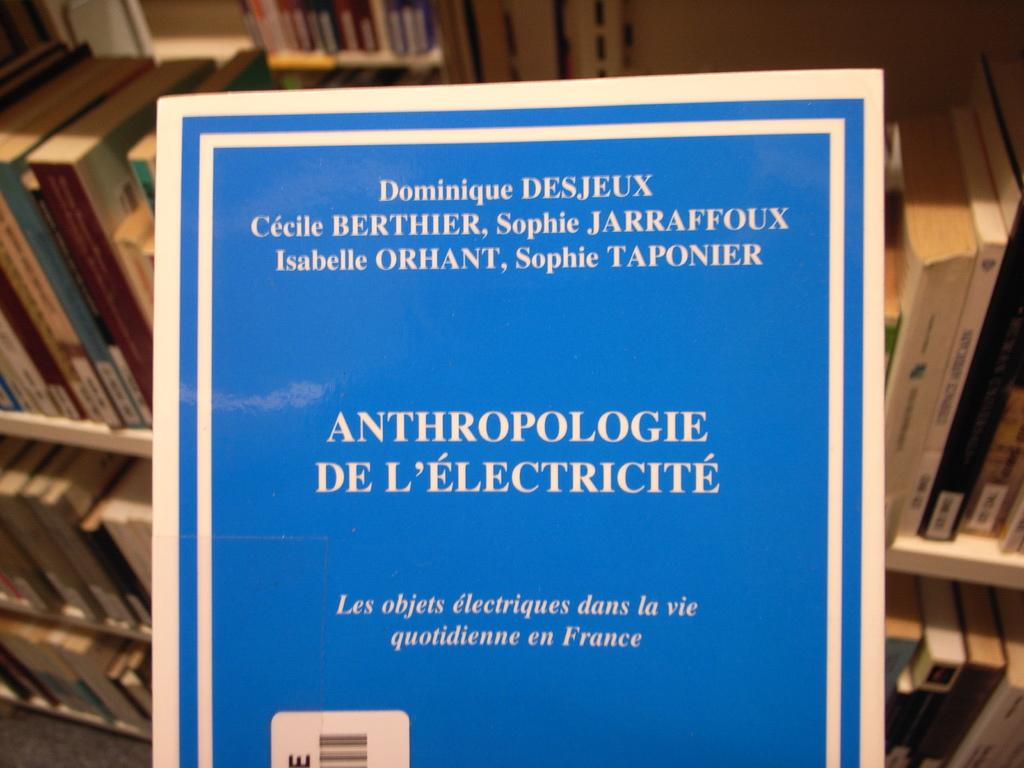<image>
Provide a brief description of the given image. A book has a blue cover and the title Anthropologie De L'Electricite. 